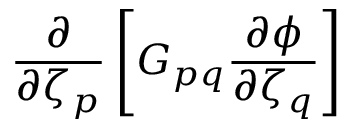<formula> <loc_0><loc_0><loc_500><loc_500>\frac { \partial } { \partial \zeta _ { p } } \left [ G _ { p q } \frac { \partial \phi } { \partial \zeta _ { q } } \right ]</formula> 